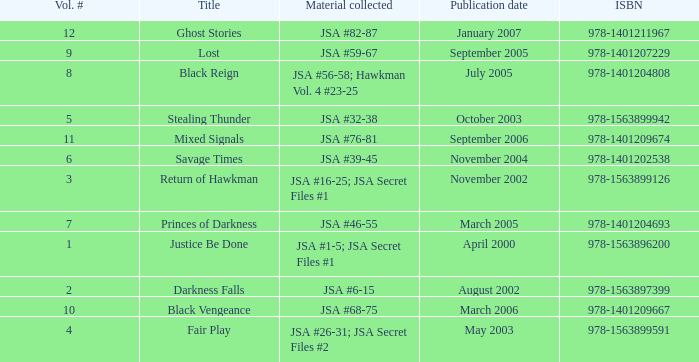What's the Lowest Volume Number that was published November 2004? 6.0. 